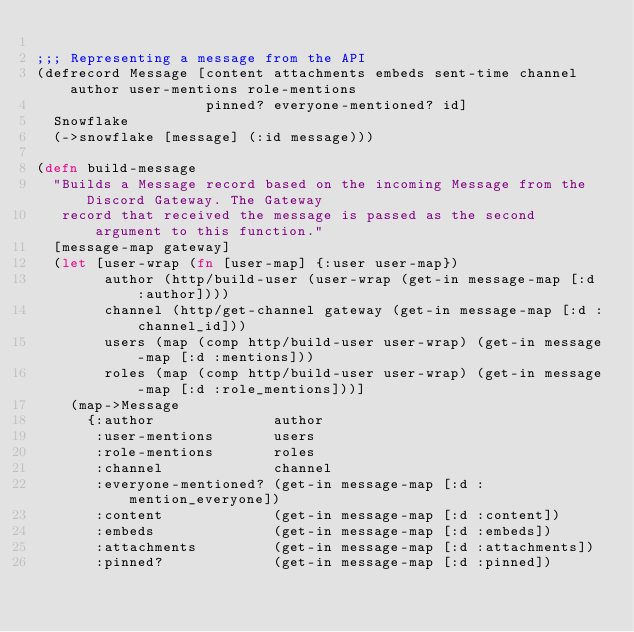Convert code to text. <code><loc_0><loc_0><loc_500><loc_500><_Clojure_>
;;; Representing a message from the API
(defrecord Message [content attachments embeds sent-time channel author user-mentions role-mentions
                    pinned? everyone-mentioned? id]
  Snowflake
  (->snowflake [message] (:id message)))

(defn build-message
  "Builds a Message record based on the incoming Message from the Discord Gateway. The Gateway
   record that received the message is passed as the second argument to this function."
  [message-map gateway]
  (let [user-wrap (fn [user-map] {:user user-map})
        author (http/build-user (user-wrap (get-in message-map [:d :author])))
        channel (http/get-channel gateway (get-in message-map [:d :channel_id]))
        users (map (comp http/build-user user-wrap) (get-in message-map [:d :mentions]))
        roles (map (comp http/build-user user-wrap) (get-in message-map [:d :role_mentions]))]
    (map->Message
      {:author              author
       :user-mentions       users
       :role-mentions       roles
       :channel             channel
       :everyone-mentioned? (get-in message-map [:d :mention_everyone])
       :content             (get-in message-map [:d :content])
       :embeds              (get-in message-map [:d :embeds])
       :attachments         (get-in message-map [:d :attachments])
       :pinned?             (get-in message-map [:d :pinned])</code> 